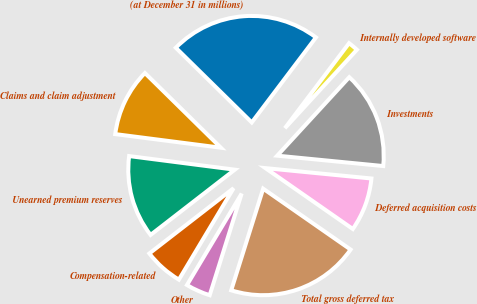<chart> <loc_0><loc_0><loc_500><loc_500><pie_chart><fcel>(at December 31 in millions)<fcel>Claims and claim adjustment<fcel>Unearned premium reserves<fcel>Compensation-related<fcel>Other<fcel>Total gross deferred tax<fcel>Deferred acquisition costs<fcel>Investments<fcel>Internally developed software<nl><fcel>22.93%<fcel>10.33%<fcel>12.53%<fcel>5.93%<fcel>3.73%<fcel>20.17%<fcel>8.13%<fcel>14.73%<fcel>1.53%<nl></chart> 